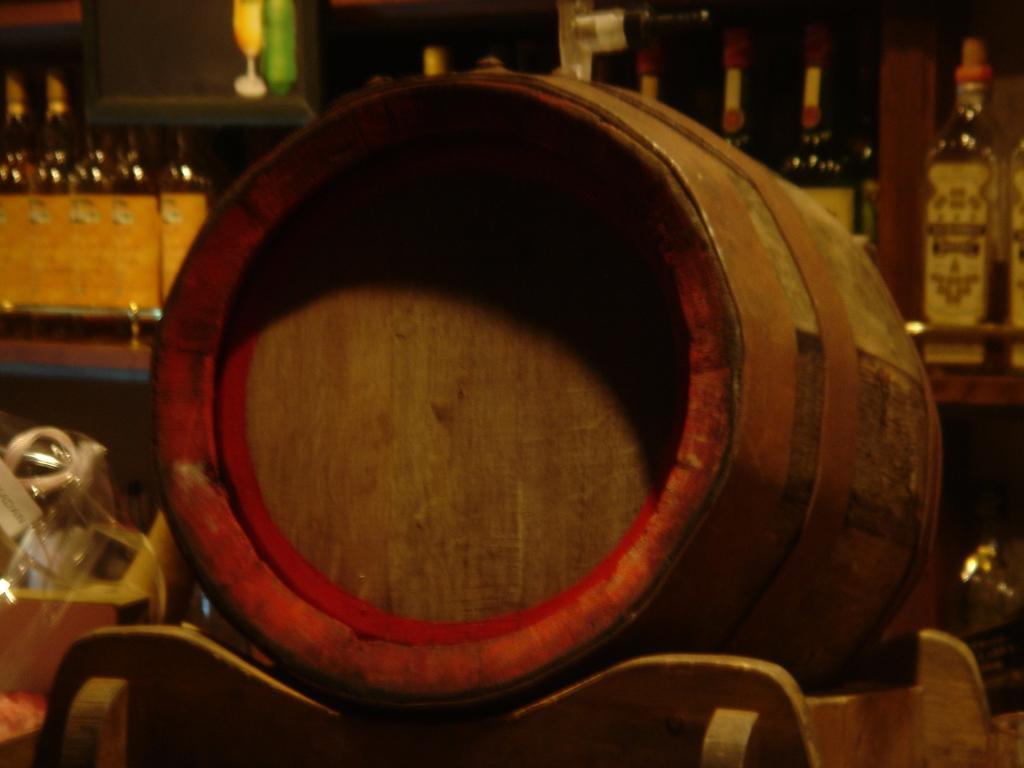In one or two sentences, can you explain what this image depicts? We can see drum on the table,cover,bottles. 